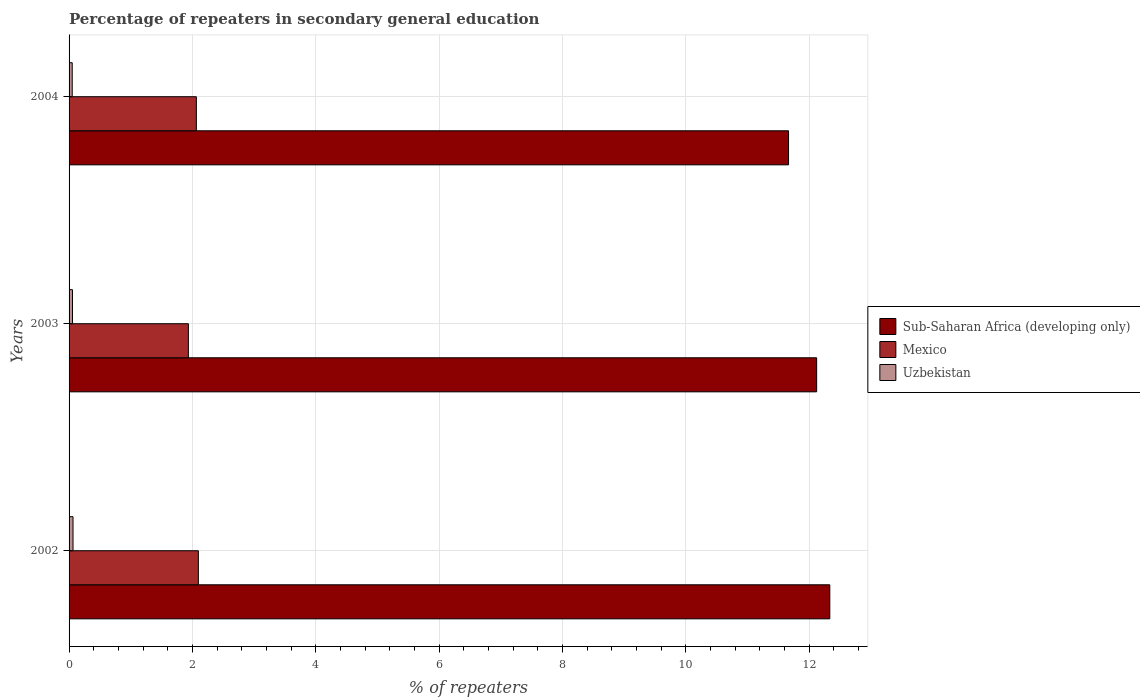How many different coloured bars are there?
Keep it short and to the point. 3. Are the number of bars per tick equal to the number of legend labels?
Your answer should be very brief. Yes. What is the percentage of repeaters in secondary general education in Sub-Saharan Africa (developing only) in 2002?
Offer a terse response. 12.33. Across all years, what is the maximum percentage of repeaters in secondary general education in Mexico?
Make the answer very short. 2.1. Across all years, what is the minimum percentage of repeaters in secondary general education in Sub-Saharan Africa (developing only)?
Offer a very short reply. 11.67. What is the total percentage of repeaters in secondary general education in Uzbekistan in the graph?
Your response must be concise. 0.17. What is the difference between the percentage of repeaters in secondary general education in Uzbekistan in 2002 and that in 2003?
Provide a short and direct response. 0.01. What is the difference between the percentage of repeaters in secondary general education in Sub-Saharan Africa (developing only) in 2003 and the percentage of repeaters in secondary general education in Mexico in 2002?
Give a very brief answer. 10.02. What is the average percentage of repeaters in secondary general education in Uzbekistan per year?
Give a very brief answer. 0.06. In the year 2002, what is the difference between the percentage of repeaters in secondary general education in Sub-Saharan Africa (developing only) and percentage of repeaters in secondary general education in Mexico?
Ensure brevity in your answer.  10.24. What is the ratio of the percentage of repeaters in secondary general education in Mexico in 2002 to that in 2003?
Your response must be concise. 1.08. Is the percentage of repeaters in secondary general education in Sub-Saharan Africa (developing only) in 2002 less than that in 2003?
Provide a succinct answer. No. Is the difference between the percentage of repeaters in secondary general education in Sub-Saharan Africa (developing only) in 2002 and 2004 greater than the difference between the percentage of repeaters in secondary general education in Mexico in 2002 and 2004?
Keep it short and to the point. Yes. What is the difference between the highest and the second highest percentage of repeaters in secondary general education in Sub-Saharan Africa (developing only)?
Make the answer very short. 0.21. What is the difference between the highest and the lowest percentage of repeaters in secondary general education in Uzbekistan?
Offer a terse response. 0.01. In how many years, is the percentage of repeaters in secondary general education in Uzbekistan greater than the average percentage of repeaters in secondary general education in Uzbekistan taken over all years?
Offer a terse response. 1. What does the 1st bar from the top in 2002 represents?
Your answer should be compact. Uzbekistan. What does the 3rd bar from the bottom in 2002 represents?
Your answer should be compact. Uzbekistan. How many bars are there?
Offer a terse response. 9. Does the graph contain any zero values?
Keep it short and to the point. No. Does the graph contain grids?
Your answer should be very brief. Yes. How many legend labels are there?
Ensure brevity in your answer.  3. How are the legend labels stacked?
Keep it short and to the point. Vertical. What is the title of the graph?
Provide a succinct answer. Percentage of repeaters in secondary general education. What is the label or title of the X-axis?
Your response must be concise. % of repeaters. What is the % of repeaters in Sub-Saharan Africa (developing only) in 2002?
Your answer should be very brief. 12.33. What is the % of repeaters in Mexico in 2002?
Your answer should be very brief. 2.1. What is the % of repeaters in Uzbekistan in 2002?
Offer a terse response. 0.06. What is the % of repeaters in Sub-Saharan Africa (developing only) in 2003?
Provide a short and direct response. 12.12. What is the % of repeaters in Mexico in 2003?
Offer a very short reply. 1.93. What is the % of repeaters in Uzbekistan in 2003?
Your answer should be very brief. 0.06. What is the % of repeaters of Sub-Saharan Africa (developing only) in 2004?
Offer a very short reply. 11.67. What is the % of repeaters of Mexico in 2004?
Provide a succinct answer. 2.06. What is the % of repeaters of Uzbekistan in 2004?
Offer a very short reply. 0.05. Across all years, what is the maximum % of repeaters of Sub-Saharan Africa (developing only)?
Provide a short and direct response. 12.33. Across all years, what is the maximum % of repeaters in Mexico?
Ensure brevity in your answer.  2.1. Across all years, what is the maximum % of repeaters of Uzbekistan?
Offer a very short reply. 0.06. Across all years, what is the minimum % of repeaters of Sub-Saharan Africa (developing only)?
Ensure brevity in your answer.  11.67. Across all years, what is the minimum % of repeaters of Mexico?
Your answer should be very brief. 1.93. Across all years, what is the minimum % of repeaters of Uzbekistan?
Make the answer very short. 0.05. What is the total % of repeaters in Sub-Saharan Africa (developing only) in the graph?
Provide a short and direct response. 36.12. What is the total % of repeaters of Mexico in the graph?
Make the answer very short. 6.09. What is the total % of repeaters in Uzbekistan in the graph?
Your answer should be compact. 0.17. What is the difference between the % of repeaters in Sub-Saharan Africa (developing only) in 2002 and that in 2003?
Offer a very short reply. 0.21. What is the difference between the % of repeaters in Mexico in 2002 and that in 2003?
Provide a short and direct response. 0.16. What is the difference between the % of repeaters in Uzbekistan in 2002 and that in 2003?
Your response must be concise. 0.01. What is the difference between the % of repeaters in Sub-Saharan Africa (developing only) in 2002 and that in 2004?
Offer a terse response. 0.67. What is the difference between the % of repeaters of Mexico in 2002 and that in 2004?
Keep it short and to the point. 0.03. What is the difference between the % of repeaters in Uzbekistan in 2002 and that in 2004?
Make the answer very short. 0.01. What is the difference between the % of repeaters in Sub-Saharan Africa (developing only) in 2003 and that in 2004?
Your answer should be very brief. 0.46. What is the difference between the % of repeaters of Mexico in 2003 and that in 2004?
Your response must be concise. -0.13. What is the difference between the % of repeaters of Uzbekistan in 2003 and that in 2004?
Provide a succinct answer. 0. What is the difference between the % of repeaters in Sub-Saharan Africa (developing only) in 2002 and the % of repeaters in Mexico in 2003?
Ensure brevity in your answer.  10.4. What is the difference between the % of repeaters in Sub-Saharan Africa (developing only) in 2002 and the % of repeaters in Uzbekistan in 2003?
Your answer should be very brief. 12.28. What is the difference between the % of repeaters in Mexico in 2002 and the % of repeaters in Uzbekistan in 2003?
Your answer should be compact. 2.04. What is the difference between the % of repeaters in Sub-Saharan Africa (developing only) in 2002 and the % of repeaters in Mexico in 2004?
Provide a succinct answer. 10.27. What is the difference between the % of repeaters of Sub-Saharan Africa (developing only) in 2002 and the % of repeaters of Uzbekistan in 2004?
Your response must be concise. 12.28. What is the difference between the % of repeaters in Mexico in 2002 and the % of repeaters in Uzbekistan in 2004?
Your answer should be compact. 2.05. What is the difference between the % of repeaters in Sub-Saharan Africa (developing only) in 2003 and the % of repeaters in Mexico in 2004?
Make the answer very short. 10.06. What is the difference between the % of repeaters in Sub-Saharan Africa (developing only) in 2003 and the % of repeaters in Uzbekistan in 2004?
Ensure brevity in your answer.  12.07. What is the difference between the % of repeaters of Mexico in 2003 and the % of repeaters of Uzbekistan in 2004?
Your answer should be compact. 1.88. What is the average % of repeaters of Sub-Saharan Africa (developing only) per year?
Provide a short and direct response. 12.04. What is the average % of repeaters in Mexico per year?
Offer a very short reply. 2.03. What is the average % of repeaters in Uzbekistan per year?
Offer a very short reply. 0.06. In the year 2002, what is the difference between the % of repeaters in Sub-Saharan Africa (developing only) and % of repeaters in Mexico?
Provide a succinct answer. 10.24. In the year 2002, what is the difference between the % of repeaters of Sub-Saharan Africa (developing only) and % of repeaters of Uzbekistan?
Offer a very short reply. 12.27. In the year 2002, what is the difference between the % of repeaters of Mexico and % of repeaters of Uzbekistan?
Provide a succinct answer. 2.03. In the year 2003, what is the difference between the % of repeaters in Sub-Saharan Africa (developing only) and % of repeaters in Mexico?
Provide a short and direct response. 10.19. In the year 2003, what is the difference between the % of repeaters of Sub-Saharan Africa (developing only) and % of repeaters of Uzbekistan?
Provide a short and direct response. 12.07. In the year 2003, what is the difference between the % of repeaters in Mexico and % of repeaters in Uzbekistan?
Give a very brief answer. 1.88. In the year 2004, what is the difference between the % of repeaters in Sub-Saharan Africa (developing only) and % of repeaters in Mexico?
Provide a succinct answer. 9.6. In the year 2004, what is the difference between the % of repeaters of Sub-Saharan Africa (developing only) and % of repeaters of Uzbekistan?
Your answer should be compact. 11.61. In the year 2004, what is the difference between the % of repeaters of Mexico and % of repeaters of Uzbekistan?
Offer a terse response. 2.01. What is the ratio of the % of repeaters of Sub-Saharan Africa (developing only) in 2002 to that in 2003?
Make the answer very short. 1.02. What is the ratio of the % of repeaters of Mexico in 2002 to that in 2003?
Provide a short and direct response. 1.08. What is the ratio of the % of repeaters of Uzbekistan in 2002 to that in 2003?
Keep it short and to the point. 1.16. What is the ratio of the % of repeaters in Sub-Saharan Africa (developing only) in 2002 to that in 2004?
Provide a succinct answer. 1.06. What is the ratio of the % of repeaters of Mexico in 2002 to that in 2004?
Offer a very short reply. 1.02. What is the ratio of the % of repeaters of Uzbekistan in 2002 to that in 2004?
Your response must be concise. 1.26. What is the ratio of the % of repeaters in Sub-Saharan Africa (developing only) in 2003 to that in 2004?
Your answer should be very brief. 1.04. What is the ratio of the % of repeaters in Mexico in 2003 to that in 2004?
Provide a short and direct response. 0.94. What is the ratio of the % of repeaters in Uzbekistan in 2003 to that in 2004?
Ensure brevity in your answer.  1.09. What is the difference between the highest and the second highest % of repeaters in Sub-Saharan Africa (developing only)?
Your response must be concise. 0.21. What is the difference between the highest and the second highest % of repeaters of Mexico?
Keep it short and to the point. 0.03. What is the difference between the highest and the second highest % of repeaters of Uzbekistan?
Provide a succinct answer. 0.01. What is the difference between the highest and the lowest % of repeaters in Sub-Saharan Africa (developing only)?
Your response must be concise. 0.67. What is the difference between the highest and the lowest % of repeaters in Mexico?
Make the answer very short. 0.16. What is the difference between the highest and the lowest % of repeaters in Uzbekistan?
Offer a very short reply. 0.01. 